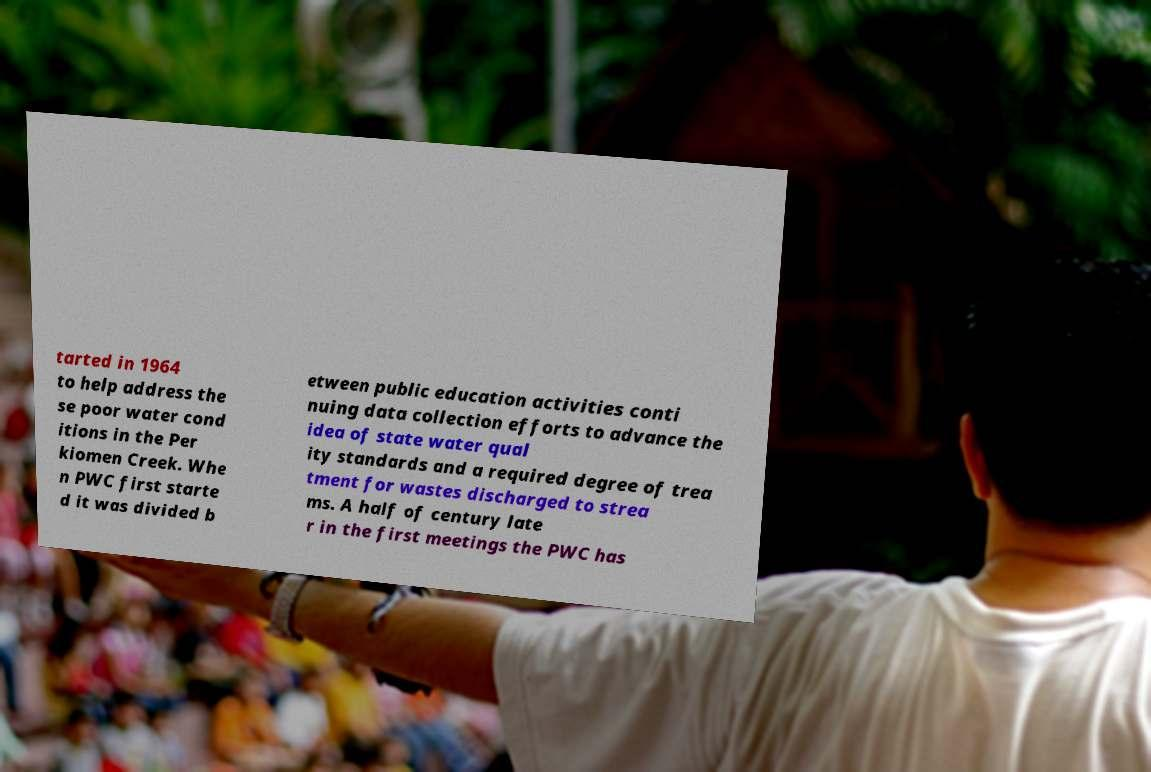I need the written content from this picture converted into text. Can you do that? tarted in 1964 to help address the se poor water cond itions in the Per kiomen Creek. Whe n PWC first starte d it was divided b etween public education activities conti nuing data collection efforts to advance the idea of state water qual ity standards and a required degree of trea tment for wastes discharged to strea ms. A half of century late r in the first meetings the PWC has 